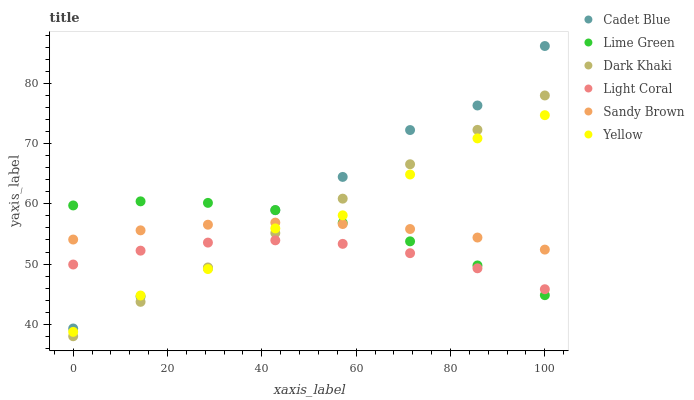Does Light Coral have the minimum area under the curve?
Answer yes or no. Yes. Does Cadet Blue have the maximum area under the curve?
Answer yes or no. Yes. Does Sandy Brown have the minimum area under the curve?
Answer yes or no. No. Does Sandy Brown have the maximum area under the curve?
Answer yes or no. No. Is Dark Khaki the smoothest?
Answer yes or no. Yes. Is Cadet Blue the roughest?
Answer yes or no. Yes. Is Sandy Brown the smoothest?
Answer yes or no. No. Is Sandy Brown the roughest?
Answer yes or no. No. Does Dark Khaki have the lowest value?
Answer yes or no. Yes. Does Cadet Blue have the lowest value?
Answer yes or no. No. Does Cadet Blue have the highest value?
Answer yes or no. Yes. Does Sandy Brown have the highest value?
Answer yes or no. No. Is Light Coral less than Sandy Brown?
Answer yes or no. Yes. Is Sandy Brown greater than Light Coral?
Answer yes or no. Yes. Does Dark Khaki intersect Light Coral?
Answer yes or no. Yes. Is Dark Khaki less than Light Coral?
Answer yes or no. No. Is Dark Khaki greater than Light Coral?
Answer yes or no. No. Does Light Coral intersect Sandy Brown?
Answer yes or no. No. 